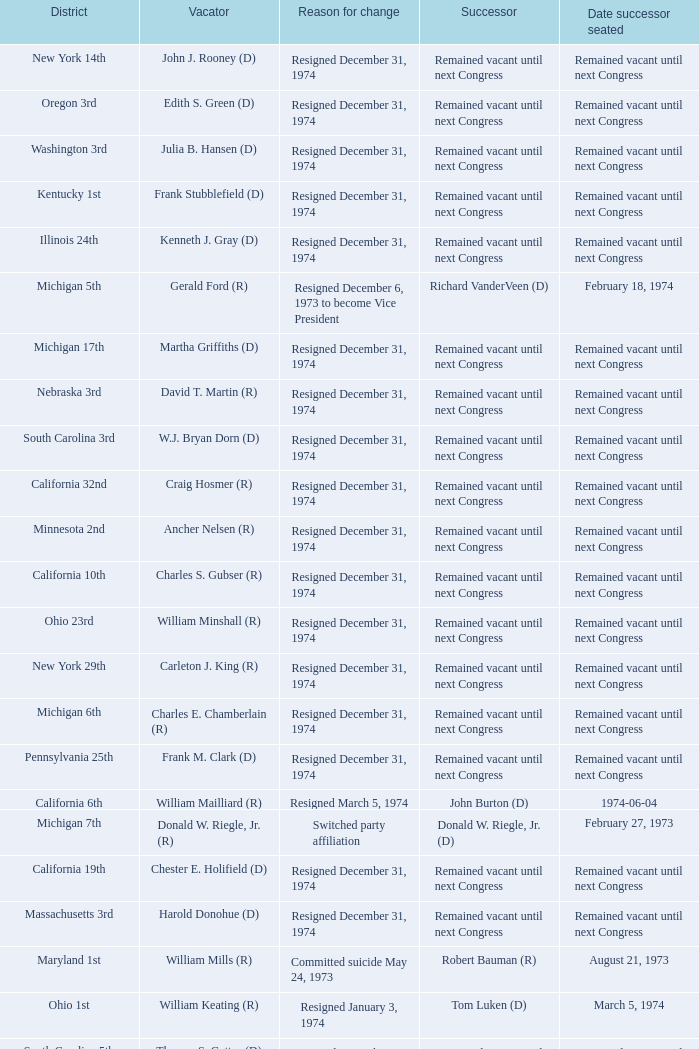Following chester e. holifield (d)'s departure, who became the successor? Remained vacant until next Congress. 